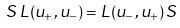<formula> <loc_0><loc_0><loc_500><loc_500>S \, L ( u _ { + } , u _ { - } ) = L ( u _ { - } , u _ { + } ) \, S \,</formula> 